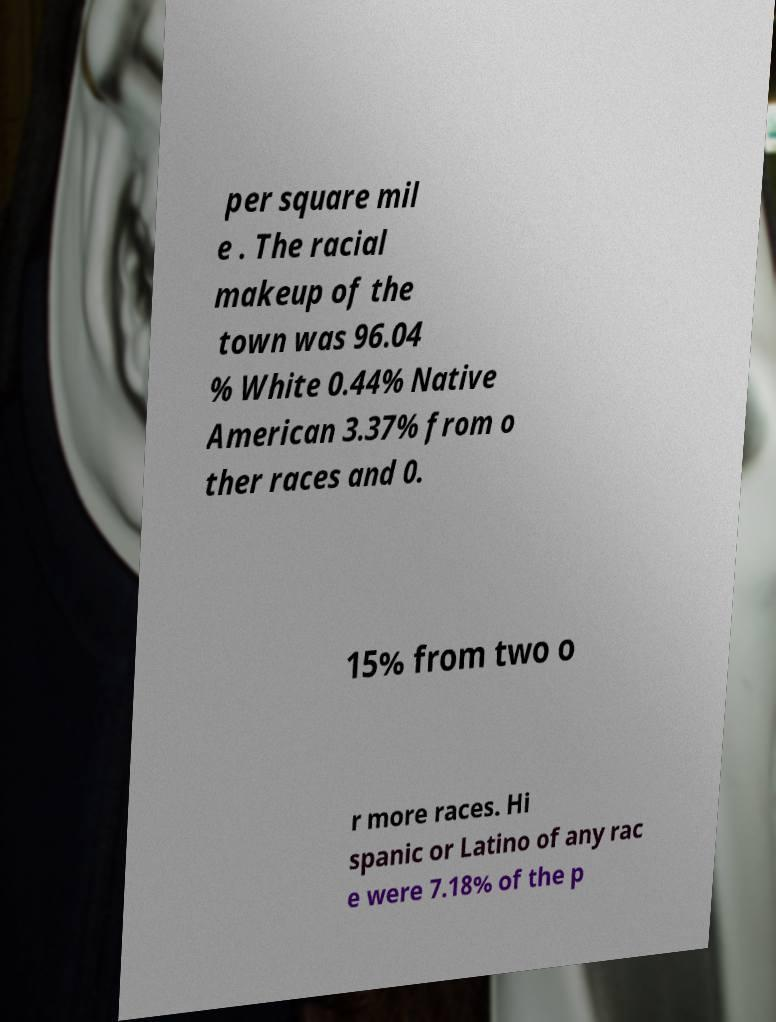For documentation purposes, I need the text within this image transcribed. Could you provide that? per square mil e . The racial makeup of the town was 96.04 % White 0.44% Native American 3.37% from o ther races and 0. 15% from two o r more races. Hi spanic or Latino of any rac e were 7.18% of the p 